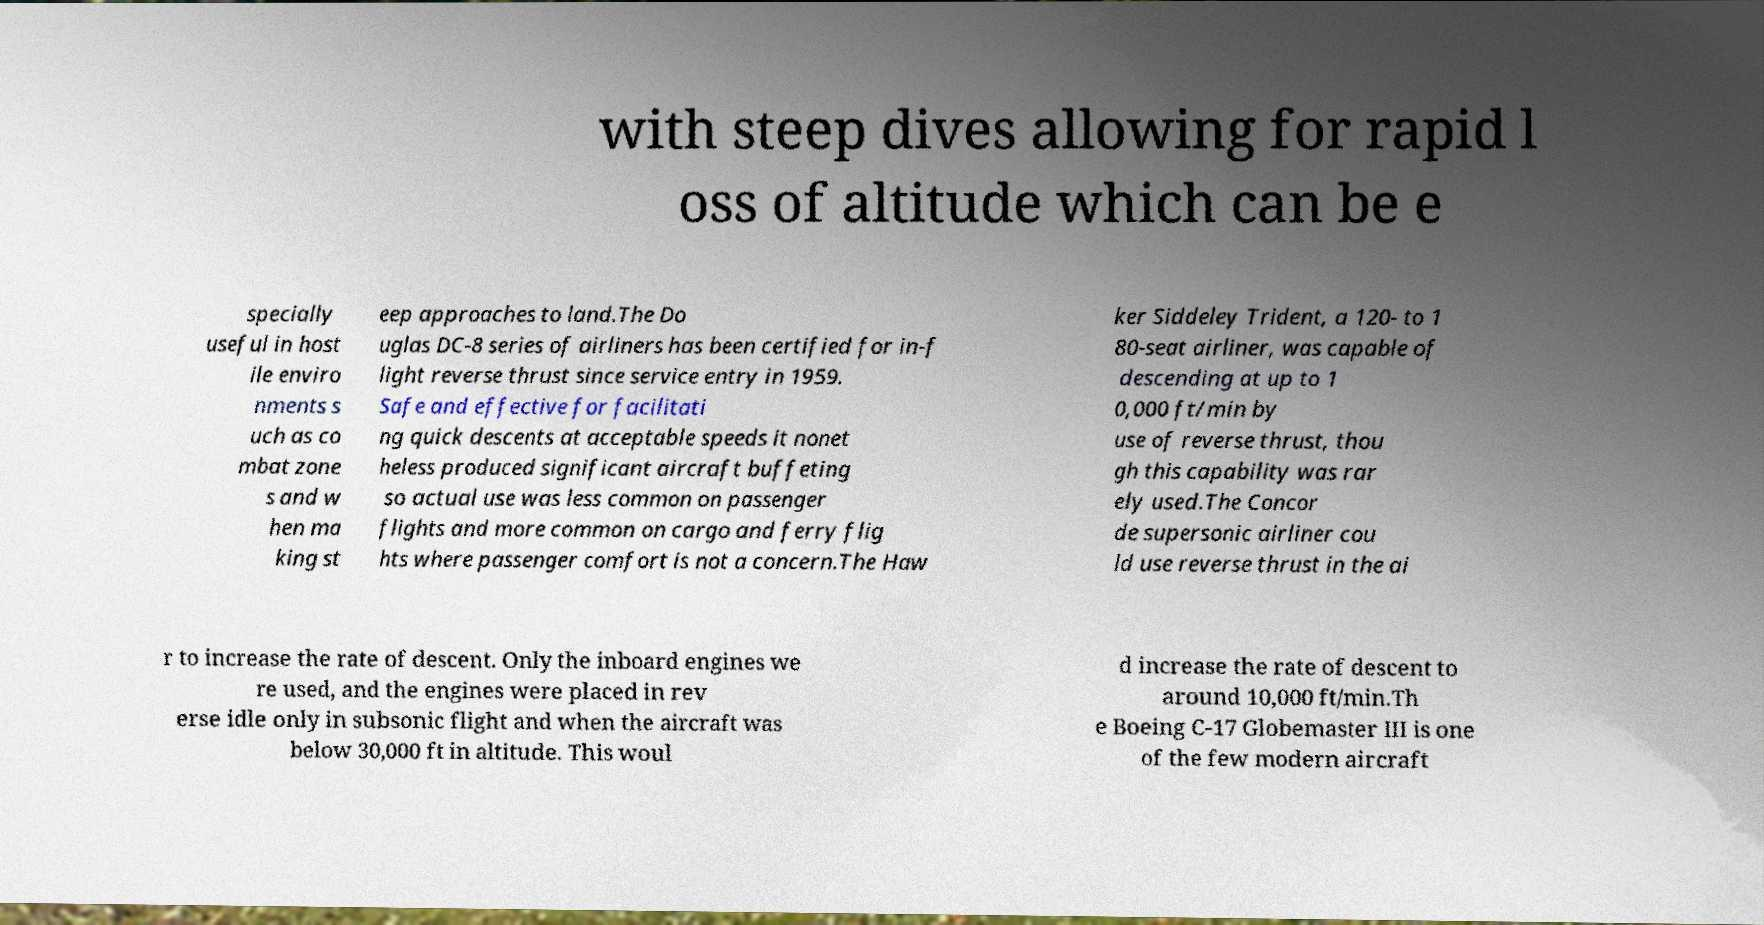I need the written content from this picture converted into text. Can you do that? with steep dives allowing for rapid l oss of altitude which can be e specially useful in host ile enviro nments s uch as co mbat zone s and w hen ma king st eep approaches to land.The Do uglas DC-8 series of airliners has been certified for in-f light reverse thrust since service entry in 1959. Safe and effective for facilitati ng quick descents at acceptable speeds it nonet heless produced significant aircraft buffeting so actual use was less common on passenger flights and more common on cargo and ferry flig hts where passenger comfort is not a concern.The Haw ker Siddeley Trident, a 120- to 1 80-seat airliner, was capable of descending at up to 1 0,000 ft/min by use of reverse thrust, thou gh this capability was rar ely used.The Concor de supersonic airliner cou ld use reverse thrust in the ai r to increase the rate of descent. Only the inboard engines we re used, and the engines were placed in rev erse idle only in subsonic flight and when the aircraft was below 30,000 ft in altitude. This woul d increase the rate of descent to around 10,000 ft/min.Th e Boeing C-17 Globemaster III is one of the few modern aircraft 